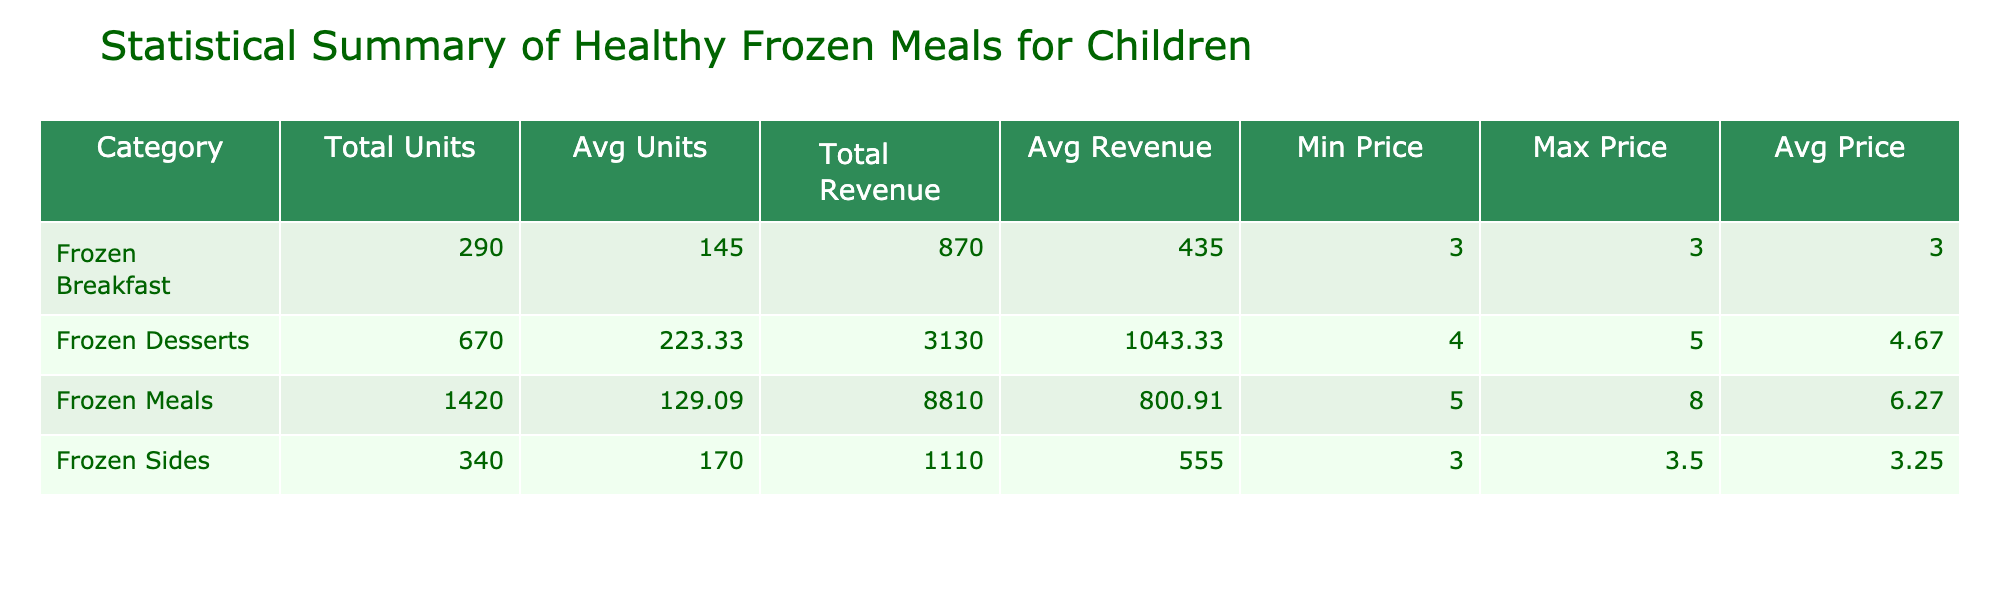What is the total revenue generated from frozen desserts? The total revenue from frozen desserts can be found by looking at the revenue values for the "Frozen Desserts" category. The relevant values are 1000 (for Fruit & Yogurt Parfaits), 880 (for Banana Oatmeal Cookies), and 1250 (for Berry Smoothie Packs). Summing them up gives 1000 + 880 + 1250 = 3130.
Answer: 3130 Which frozen meal has the highest average price per unit? To find the highest average price per unit, I need to look at the "Avg Price" column in the table. By comparing the average prices of the frozen meals, we can see the maximum value. It appears that "Chicken & Quinoa Bowl" and "Vegetable Quinoa Burger" both have an average price of 8.00, which is the highest.
Answer: 8.00 How many total units of frozen meals were sold in Week 2? To find the total units sold in Week 2, check the "Units Sold" column for entries where the week is 2. Those entries are "Turkey Meatballs" (160), "Vegetable Stir Fry" (130), "Whole Grain Pancakes" (140), and "Mini Pizzas with Veggies" (170). Adding them gives 160 + 130 + 140 + 170 = 600.
Answer: 600 Did "Sweet Potato Fries" generate more revenue than "Zucchini Fries"? To compare revenues, look at the revenue generated by each product. "Sweet Potato Fries" generated 630, while "Zucchini Fries" generated 480. Since 630 is greater than 480, the statement is true.
Answer: Yes What is the percentage increase in total units sold from Week 1 to Week 3? First, calculate the total units sold for Week 1 (150 + 120 + 100 + 180 + 140 + 110 + 200 = 1,100) and for Week 3 (130 + 90 + 150 + 120 + 160 + 250 = 1,000). To find the percentage change: ((Total Week 3 - Total Week 1) / Total Week 1) * 100 = ((1000 - 1100) / 1100) * 100 = -9.09%. Therefore, it actually represents a decrease.
Answer: -9.09% Which category had the least average units sold? To determine which category had the least average units sold, I look at the "Avg Units" column. Upon reviewing the values, "Frozen Breakfast" has 130, which is less than the averages of the other categories (Frozen Meals, Frozen Sides, and Frozen Desserts).
Answer: Frozen Breakfast 